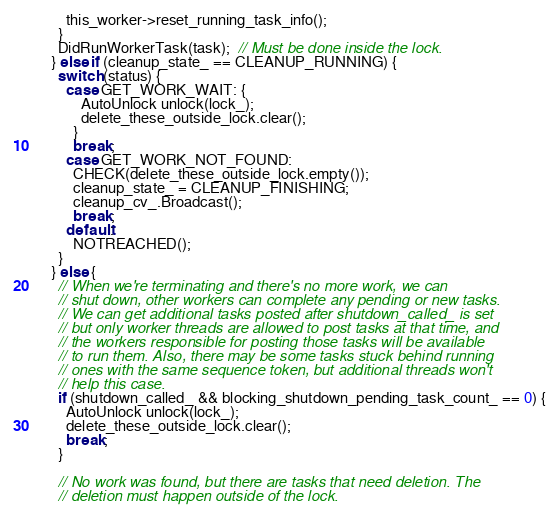<code> <loc_0><loc_0><loc_500><loc_500><_C++_>          this_worker->reset_running_task_info();
        }
        DidRunWorkerTask(task);  // Must be done inside the lock.
      } else if (cleanup_state_ == CLEANUP_RUNNING) {
        switch (status) {
          case GET_WORK_WAIT: {
              AutoUnlock unlock(lock_);
              delete_these_outside_lock.clear();
            }
            break;
          case GET_WORK_NOT_FOUND:
            CHECK(delete_these_outside_lock.empty());
            cleanup_state_ = CLEANUP_FINISHING;
            cleanup_cv_.Broadcast();
            break;
          default:
            NOTREACHED();
        }
      } else {
        // When we're terminating and there's no more work, we can
        // shut down, other workers can complete any pending or new tasks.
        // We can get additional tasks posted after shutdown_called_ is set
        // but only worker threads are allowed to post tasks at that time, and
        // the workers responsible for posting those tasks will be available
        // to run them. Also, there may be some tasks stuck behind running
        // ones with the same sequence token, but additional threads won't
        // help this case.
        if (shutdown_called_ && blocking_shutdown_pending_task_count_ == 0) {
          AutoUnlock unlock(lock_);
          delete_these_outside_lock.clear();
          break;
        }

        // No work was found, but there are tasks that need deletion. The
        // deletion must happen outside of the lock.</code> 